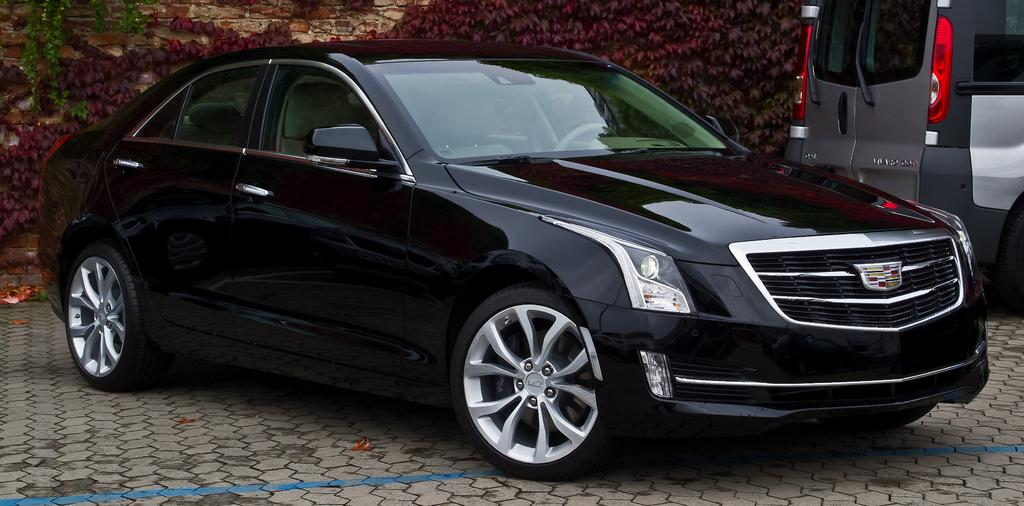What is the color of the main vehicle in the image? The main vehicle in the image is black-colored. Can you describe the other vehicle in the image? The other vehicle in the image has black and gray colors. What type of natural elements can be seen in the image? There are plants in the image, with a green color. Can you tell me how many pigs are visible in the image? There are no pigs present in the image. What type of nut is being delivered by the vehicle in the image? There is no nut being delivered in the image, as the vehicles are not shown transporting any items. 